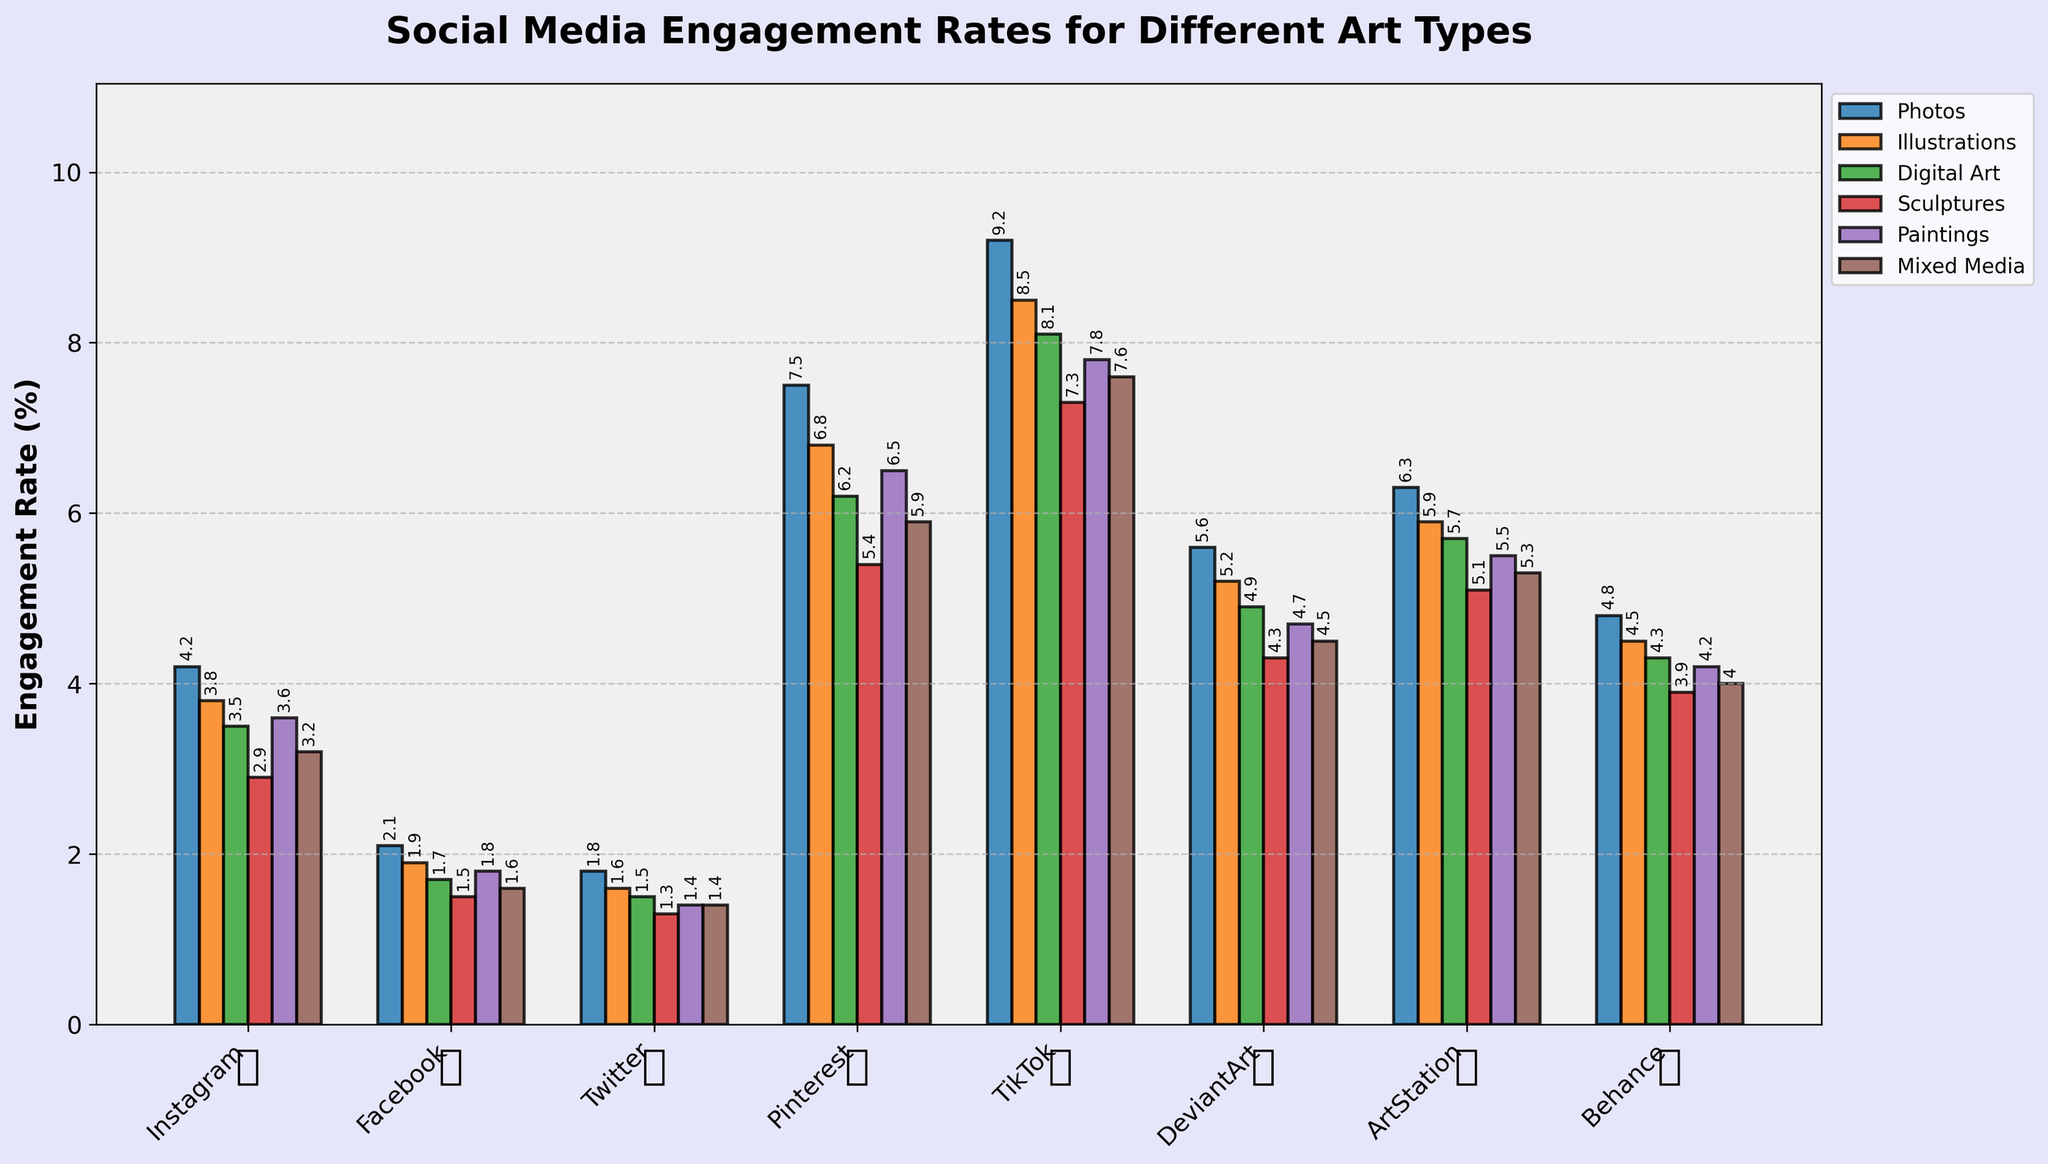Which platform has the highest engagement rate for photos? Look at the bars representing photos across all platforms and find the tallest one. TikTok's bar for photos is the highest at 9.2%.
Answer: TikTok How does the engagement rate for digital art on DeviantArt compare to that on Instagram? Identify the bar for digital art on DeviantArt (4.9%) and the bar for digital art on Instagram (3.5%). Compare the two values. 4.9% is greater than 3.5%.
Answer: Higher What's the average engagement rate for sculptures on all platforms? Collect the engagement rates for sculptures on all platforms: 2.9, 1.5, 1.3, 5.4, 7.3, 4.3, 5.1, 3.9. Add them up: 2.9+1.5+1.3+5.4+7.3+4.3+5.1+3.9 = 31.7. Divide by the number of platforms (8): 31.7/8 = 3.96
Answer: 3.96 Which art type generally has the lowest engagement rates across all platforms? Summarize each art type's total engagement rates across platforms: photos (4.2+2.1+1.8+7.5+9.2+5.6+6.3+4.8), illustrations (3.8+1.9+1.6+6.8+8.5+5.2+5.9+4.5), digital art (3.5+1.7+1.5+6.2+8.1+4.9+5.7+4.3), etc. Compare the totals. Digital art has the lowest sum.
Answer: Digital art What is the difference in engagement rates for mixed media between Pinterest and Facebook? Identify the engagement rates for mixed media on Pinterest (5.9%) and Facebook (1.6%). Subtract the smaller value from the larger one. 5.9 - 1.6 = 4.3
Answer: 4.3 Which platform shows the smallest range in engagement rates across different art types? Find the range (max - min) for each platform: Instagram (4.2-2.9 = 1.3), Facebook (2.1-1.5 = 0.6), Twitter (1.8-1.3 = 0.5), etc. Twitter shows the smallest range.
Answer: Twitter How do engagement rates for paintings on ArtStation and Behance compare? Identify the engagement rates for paintings on ArtStation (5.5%) and Behance (4.2%). Compare 5.5 and 4.2. 5.5 is greater than 4.2.
Answer: ArtStation is higher What's the median engagement rate for all platform-data for illustrations? List the engagement rates for illustrations across all platforms: 3.8, 1.9, 1.6, 6.8, 8.5, 5.2, 5.9, 4.5. Sort them: 1.6, 1.9, 3.8, 4.5, 5.2, 5.9, 6.8, 8.5. Median is average of middle values (4.5+5.2)/2 = 4.85
Answer: 4.85 Which art type on TikTok has the lowest engagement rate? Look at the bars for TikTok and identify the shortest bar. The shortest bar is for sculptures at 7.3%.
Answer: Sculptures What is the total engagement rate for Facebook for all art types combined? Sum the engagement rates for each art type on Facebook: 2.1+1.9+1.7+1.5+1.8+1.6 = 10.6
Answer: 10.6 